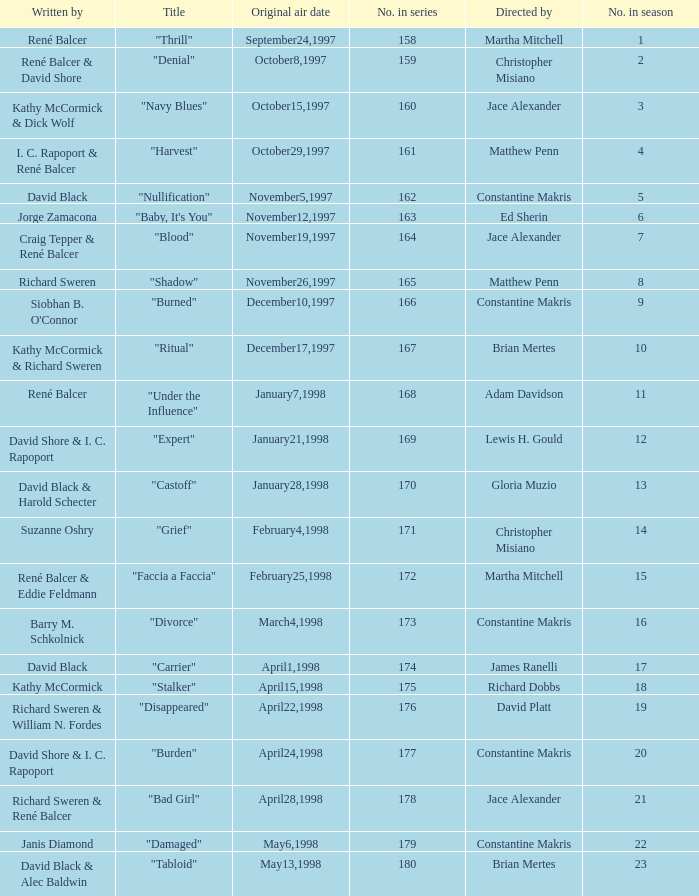Name the title of the episode that ed sherin directed. "Baby, It's You". 